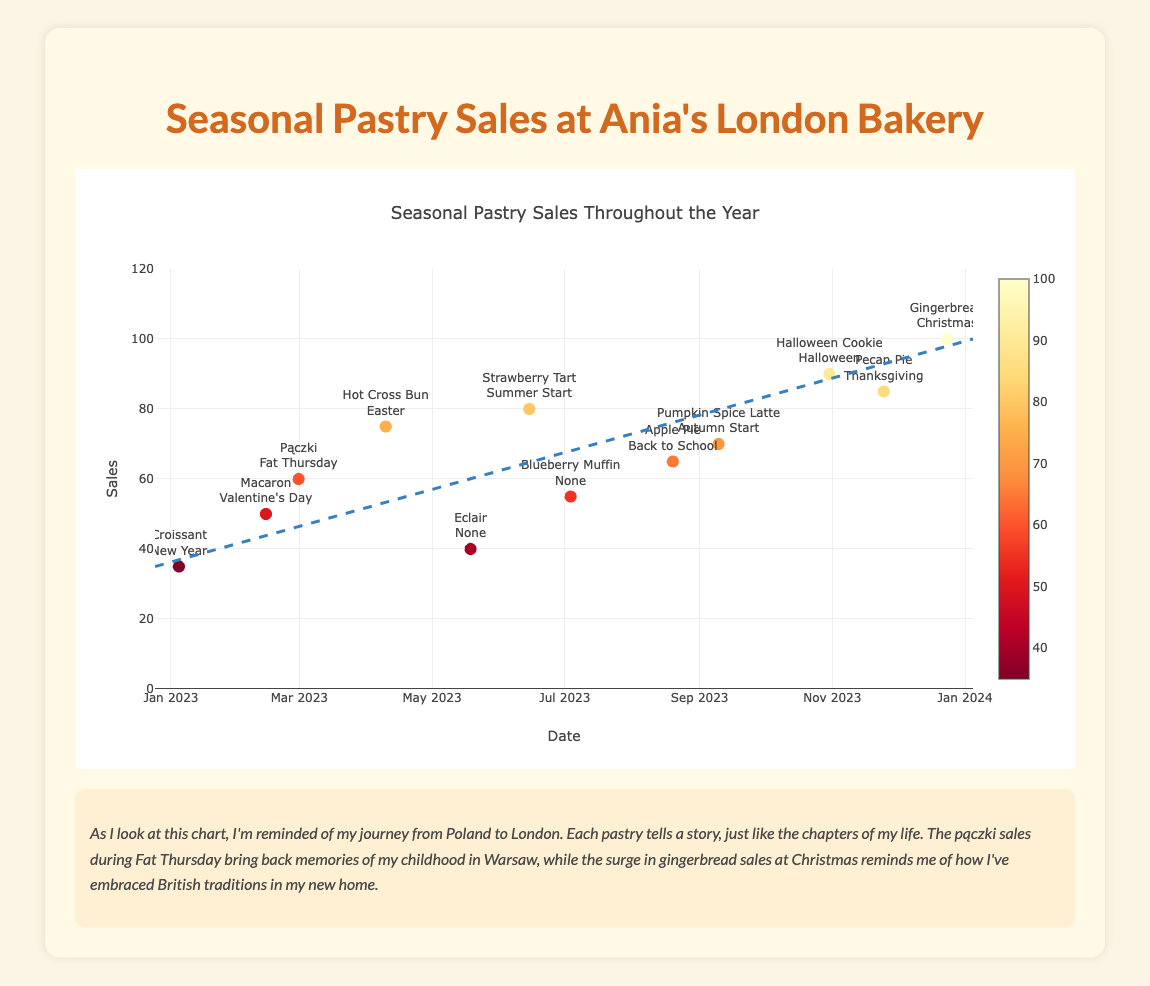Which pastry had the highest sales? The highest sales can be observed by identifying the data point with the maximum 'sales' value. The 'Gingerbread' sold during Christmas has the highest sales at 100.
Answer: Gingerbread Which seasonal event had the lowest sales? The lowest sales can be observed by identifying the data point with the minimum 'sales' value among those with a seasonal event. The 'Croissant' during New Year had the lowest sales at 35.
Answer: New Year What is the overall trend of sales throughout the year? The trendline in the scatter plot indicates a general upward trend, starting from around 35 sales in January and reaching around 100 sales by December.
Answer: Upward How much higher were the sales of Halloween Cookies compared to Croissants? The sales of Halloween Cookies are 90, and the sales of Croissants are 35. The difference is 90 - 35 = 55.
Answer: 55 Are there any months with no seasonal events shown on the plot? By checking the 'seasonal_event' field, it's clear that both May (Eclair) and July (Blueberry Muffin) have "None" as their seasonal event.
Answer: May and July How do the sales of Pączki on Fat Thursday compare to those of the Hot Cross Buns at Easter? The sales of Pączki are 60, and the sales of Hot Cross Buns are 75. Comparing them, Hot Cross Buns have higher sales by 75 - 60 = 15.
Answer: Hot Cross Buns have 15 more What can you infer about sales during holiday seasons in comparison to non-seasonal periods? Observing the scatter plot, sales during holiday seasons (e.g., Valentine's Day, Easter, Halloween, Christmas) are generally higher compared to non-seasonal periods. For instance, Gingerbread during Christmas had 100 sales versus Blueberry Muffin in non-seasonal July with 55 sales.
Answer: Higher during holidays Which month saw the highest increase in sales compared to the previous month? Calculating month-by-month differences, the greatest jump is from June (80 sales for Strawberry Tart) to July (55 sales for Blueberry Muffin) which is actually a decrease. However, from July (55) to August (65 for Apple Pie) yields a 10 unit increase. Larger month-to-month specific comparisons would need deeper breakdowns per step.
Answer: August (largest relative month-to-month increase visually) What is the range of sales values observed in the plot? The range of sales values is determined by subtracting the minimum sales value from the maximum sales value. The minimum is 35 (Croissant) and the maximum is 100 (Gingerbread), so the range is 100 - 35 = 65.
Answer: 65 